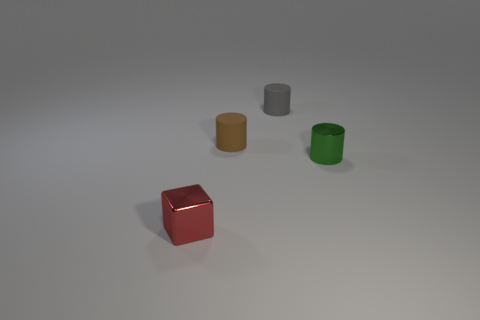Does the tiny brown matte thing have the same shape as the gray thing?
Keep it short and to the point. Yes. There is a object that is both in front of the tiny brown matte thing and to the right of the cube; how big is it?
Keep it short and to the point. Small. There is another small matte object that is the same shape as the brown matte thing; what color is it?
Offer a very short reply. Gray. There is a rubber object that is on the left side of the tiny gray matte cylinder; is there a small red shiny cube that is behind it?
Make the answer very short. No. How many yellow cylinders are there?
Offer a very short reply. 0. Are there more tiny matte cylinders than small cylinders?
Provide a succinct answer. No. What number of other objects are the same size as the metal cylinder?
Keep it short and to the point. 3. The small cylinder that is to the right of the small gray object that is to the left of the shiny object that is behind the metallic cube is made of what material?
Provide a short and direct response. Metal. Does the brown object have the same material as the gray cylinder that is behind the tiny green object?
Offer a terse response. Yes. Are there fewer tiny red metallic objects that are in front of the metal cube than objects that are on the left side of the green shiny cylinder?
Your response must be concise. Yes. 